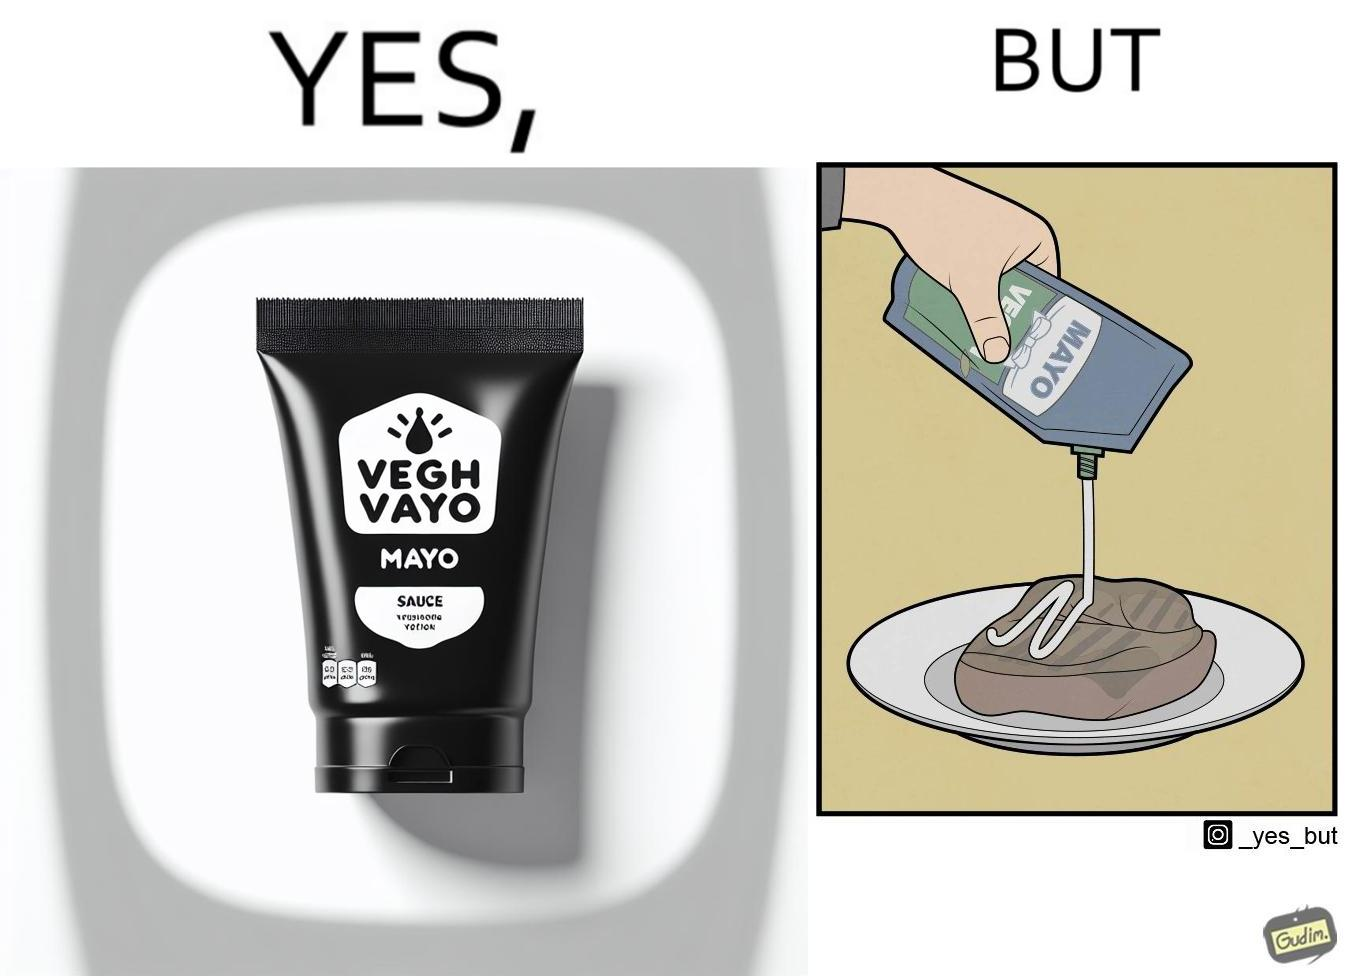Explain the humor or irony in this image. The image is ironical, as vegan mayo sauce is being poured on rib steak, which is non-vegetarian. The person might as well just use normal mayo sauce instead. 